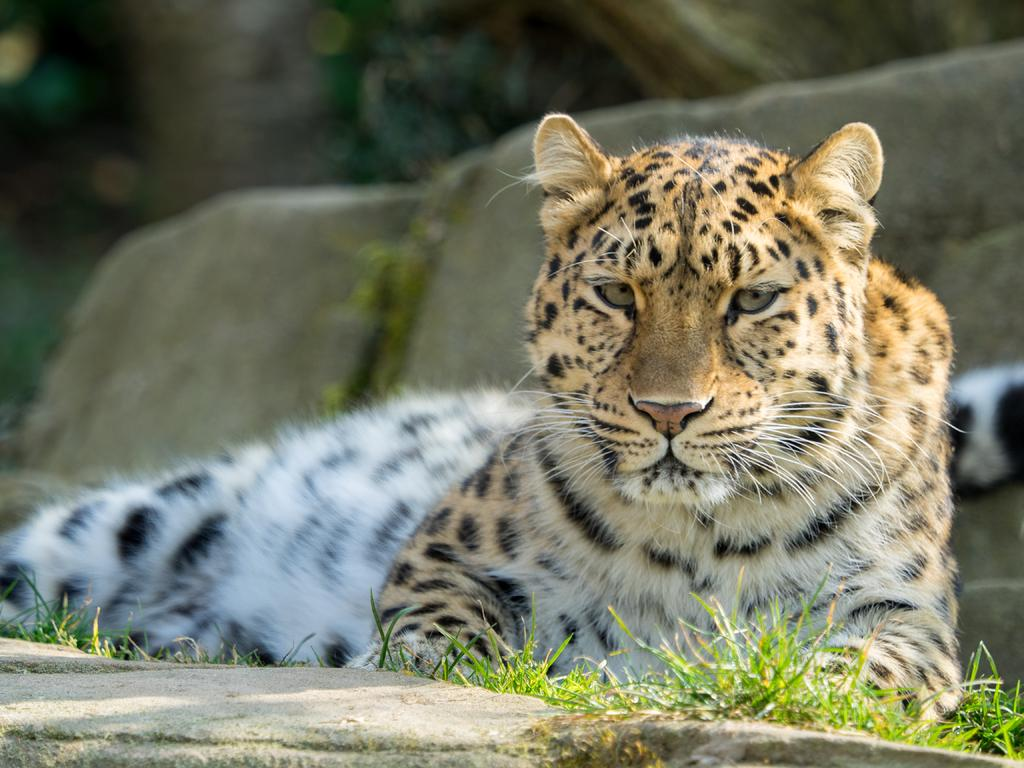What animal is in the image? There is a tiger in the image. What is the tiger doing in the image? The tiger is sitting. What colors can be seen on the tiger? The tiger has brown, black, and white coloring. What type of natural elements are visible in the image? There are rocks and trees with green color in the image. What type of flag is being waved by the tiger in the image? There is no flag present in the image, and the tiger is not waving anything. --- 